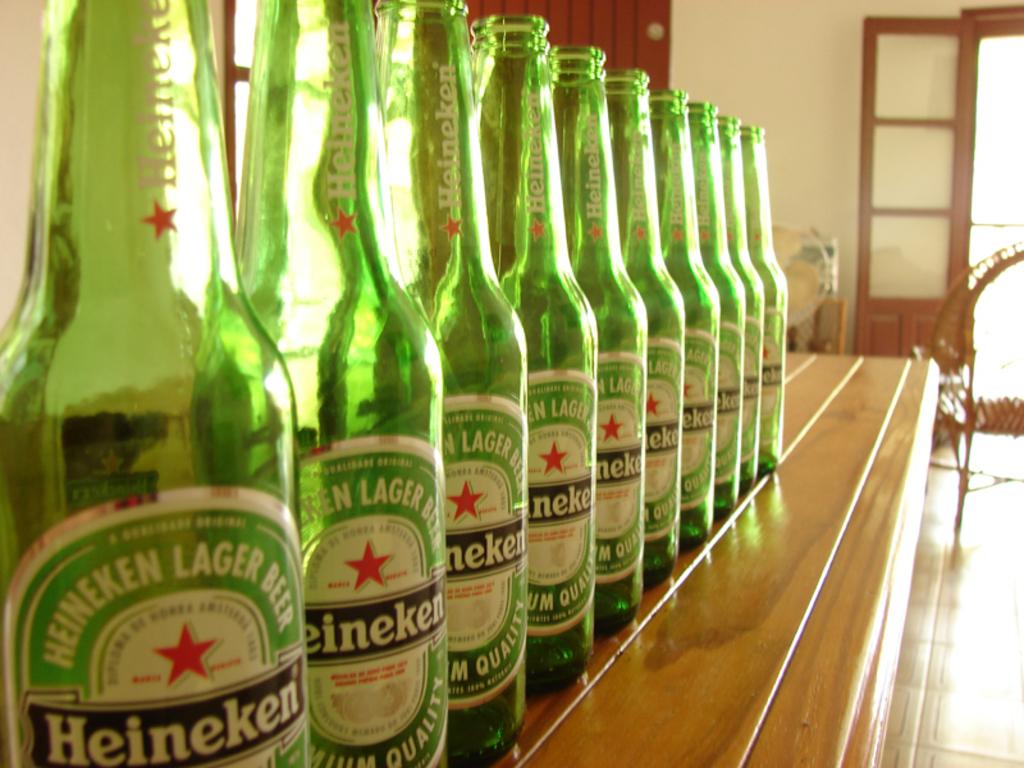What brand of beer are these bottles?
Provide a short and direct response. Heineken. What type of beer is this?
Your answer should be very brief. Heineken. 